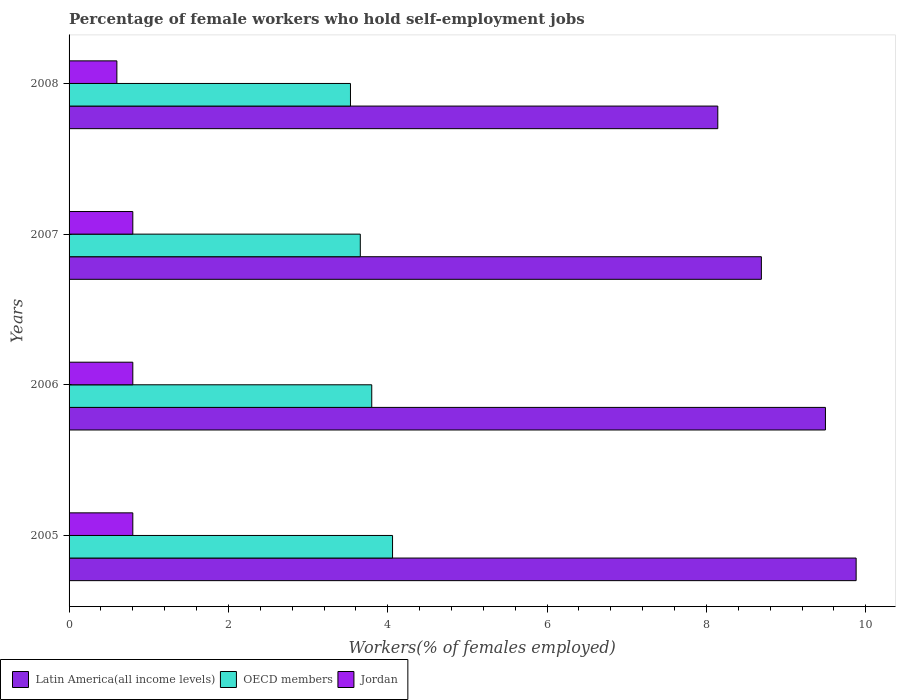Are the number of bars per tick equal to the number of legend labels?
Provide a short and direct response. Yes. Are the number of bars on each tick of the Y-axis equal?
Your response must be concise. Yes. How many bars are there on the 3rd tick from the bottom?
Offer a very short reply. 3. What is the label of the 3rd group of bars from the top?
Your answer should be very brief. 2006. What is the percentage of self-employed female workers in Latin America(all income levels) in 2007?
Provide a short and direct response. 8.69. Across all years, what is the maximum percentage of self-employed female workers in Jordan?
Make the answer very short. 0.8. Across all years, what is the minimum percentage of self-employed female workers in OECD members?
Offer a terse response. 3.53. In which year was the percentage of self-employed female workers in Latin America(all income levels) maximum?
Your answer should be very brief. 2005. In which year was the percentage of self-employed female workers in Latin America(all income levels) minimum?
Your response must be concise. 2008. What is the total percentage of self-employed female workers in Latin America(all income levels) in the graph?
Ensure brevity in your answer.  36.2. What is the difference between the percentage of self-employed female workers in OECD members in 2007 and that in 2008?
Make the answer very short. 0.12. What is the difference between the percentage of self-employed female workers in Latin America(all income levels) in 2005 and the percentage of self-employed female workers in Jordan in 2007?
Ensure brevity in your answer.  9.08. What is the average percentage of self-employed female workers in Latin America(all income levels) per year?
Provide a succinct answer. 9.05. In the year 2008, what is the difference between the percentage of self-employed female workers in OECD members and percentage of self-employed female workers in Latin America(all income levels)?
Your response must be concise. -4.61. In how many years, is the percentage of self-employed female workers in Latin America(all income levels) greater than 0.8 %?
Provide a short and direct response. 4. What is the ratio of the percentage of self-employed female workers in Latin America(all income levels) in 2007 to that in 2008?
Offer a very short reply. 1.07. Is the percentage of self-employed female workers in Latin America(all income levels) in 2005 less than that in 2007?
Give a very brief answer. No. Is the difference between the percentage of self-employed female workers in OECD members in 2007 and 2008 greater than the difference between the percentage of self-employed female workers in Latin America(all income levels) in 2007 and 2008?
Give a very brief answer. No. What is the difference between the highest and the second highest percentage of self-employed female workers in OECD members?
Your answer should be compact. 0.26. What is the difference between the highest and the lowest percentage of self-employed female workers in OECD members?
Keep it short and to the point. 0.53. In how many years, is the percentage of self-employed female workers in Latin America(all income levels) greater than the average percentage of self-employed female workers in Latin America(all income levels) taken over all years?
Ensure brevity in your answer.  2. Is the sum of the percentage of self-employed female workers in Latin America(all income levels) in 2005 and 2008 greater than the maximum percentage of self-employed female workers in Jordan across all years?
Offer a very short reply. Yes. What does the 2nd bar from the top in 2006 represents?
Ensure brevity in your answer.  OECD members. What does the 3rd bar from the bottom in 2008 represents?
Your answer should be compact. Jordan. Is it the case that in every year, the sum of the percentage of self-employed female workers in OECD members and percentage of self-employed female workers in Latin America(all income levels) is greater than the percentage of self-employed female workers in Jordan?
Ensure brevity in your answer.  Yes. How many bars are there?
Your response must be concise. 12. Are all the bars in the graph horizontal?
Keep it short and to the point. Yes. How many years are there in the graph?
Make the answer very short. 4. Does the graph contain any zero values?
Provide a short and direct response. No. Does the graph contain grids?
Offer a very short reply. No. Where does the legend appear in the graph?
Provide a short and direct response. Bottom left. How many legend labels are there?
Offer a very short reply. 3. What is the title of the graph?
Offer a terse response. Percentage of female workers who hold self-employment jobs. Does "Guyana" appear as one of the legend labels in the graph?
Offer a very short reply. No. What is the label or title of the X-axis?
Your answer should be compact. Workers(% of females employed). What is the Workers(% of females employed) in Latin America(all income levels) in 2005?
Keep it short and to the point. 9.88. What is the Workers(% of females employed) of OECD members in 2005?
Provide a short and direct response. 4.06. What is the Workers(% of females employed) of Jordan in 2005?
Provide a short and direct response. 0.8. What is the Workers(% of females employed) in Latin America(all income levels) in 2006?
Provide a short and direct response. 9.49. What is the Workers(% of females employed) of OECD members in 2006?
Give a very brief answer. 3.8. What is the Workers(% of females employed) in Jordan in 2006?
Make the answer very short. 0.8. What is the Workers(% of females employed) of Latin America(all income levels) in 2007?
Keep it short and to the point. 8.69. What is the Workers(% of females employed) of OECD members in 2007?
Your answer should be very brief. 3.66. What is the Workers(% of females employed) of Jordan in 2007?
Provide a short and direct response. 0.8. What is the Workers(% of females employed) of Latin America(all income levels) in 2008?
Your answer should be compact. 8.14. What is the Workers(% of females employed) in OECD members in 2008?
Provide a succinct answer. 3.53. What is the Workers(% of females employed) of Jordan in 2008?
Your answer should be very brief. 0.6. Across all years, what is the maximum Workers(% of females employed) of Latin America(all income levels)?
Offer a very short reply. 9.88. Across all years, what is the maximum Workers(% of females employed) of OECD members?
Keep it short and to the point. 4.06. Across all years, what is the maximum Workers(% of females employed) of Jordan?
Your response must be concise. 0.8. Across all years, what is the minimum Workers(% of females employed) of Latin America(all income levels)?
Offer a very short reply. 8.14. Across all years, what is the minimum Workers(% of females employed) of OECD members?
Offer a very short reply. 3.53. Across all years, what is the minimum Workers(% of females employed) of Jordan?
Your answer should be very brief. 0.6. What is the total Workers(% of females employed) of Latin America(all income levels) in the graph?
Offer a terse response. 36.2. What is the total Workers(% of females employed) of OECD members in the graph?
Your response must be concise. 15.05. What is the difference between the Workers(% of females employed) of Latin America(all income levels) in 2005 and that in 2006?
Your answer should be very brief. 0.39. What is the difference between the Workers(% of females employed) in OECD members in 2005 and that in 2006?
Provide a short and direct response. 0.26. What is the difference between the Workers(% of females employed) of Latin America(all income levels) in 2005 and that in 2007?
Offer a very short reply. 1.19. What is the difference between the Workers(% of females employed) of OECD members in 2005 and that in 2007?
Provide a succinct answer. 0.4. What is the difference between the Workers(% of females employed) in Jordan in 2005 and that in 2007?
Ensure brevity in your answer.  0. What is the difference between the Workers(% of females employed) in Latin America(all income levels) in 2005 and that in 2008?
Ensure brevity in your answer.  1.74. What is the difference between the Workers(% of females employed) of OECD members in 2005 and that in 2008?
Offer a very short reply. 0.53. What is the difference between the Workers(% of females employed) of Latin America(all income levels) in 2006 and that in 2007?
Offer a terse response. 0.8. What is the difference between the Workers(% of females employed) of OECD members in 2006 and that in 2007?
Your response must be concise. 0.14. What is the difference between the Workers(% of females employed) in Latin America(all income levels) in 2006 and that in 2008?
Provide a short and direct response. 1.35. What is the difference between the Workers(% of females employed) of OECD members in 2006 and that in 2008?
Make the answer very short. 0.27. What is the difference between the Workers(% of females employed) of Jordan in 2006 and that in 2008?
Your answer should be very brief. 0.2. What is the difference between the Workers(% of females employed) in Latin America(all income levels) in 2007 and that in 2008?
Your answer should be very brief. 0.55. What is the difference between the Workers(% of females employed) of OECD members in 2007 and that in 2008?
Keep it short and to the point. 0.12. What is the difference between the Workers(% of females employed) in Latin America(all income levels) in 2005 and the Workers(% of females employed) in OECD members in 2006?
Give a very brief answer. 6.08. What is the difference between the Workers(% of females employed) in Latin America(all income levels) in 2005 and the Workers(% of females employed) in Jordan in 2006?
Ensure brevity in your answer.  9.08. What is the difference between the Workers(% of females employed) in OECD members in 2005 and the Workers(% of females employed) in Jordan in 2006?
Your response must be concise. 3.26. What is the difference between the Workers(% of females employed) in Latin America(all income levels) in 2005 and the Workers(% of females employed) in OECD members in 2007?
Make the answer very short. 6.22. What is the difference between the Workers(% of females employed) in Latin America(all income levels) in 2005 and the Workers(% of females employed) in Jordan in 2007?
Make the answer very short. 9.08. What is the difference between the Workers(% of females employed) of OECD members in 2005 and the Workers(% of females employed) of Jordan in 2007?
Your answer should be very brief. 3.26. What is the difference between the Workers(% of females employed) in Latin America(all income levels) in 2005 and the Workers(% of females employed) in OECD members in 2008?
Keep it short and to the point. 6.35. What is the difference between the Workers(% of females employed) of Latin America(all income levels) in 2005 and the Workers(% of females employed) of Jordan in 2008?
Make the answer very short. 9.28. What is the difference between the Workers(% of females employed) in OECD members in 2005 and the Workers(% of females employed) in Jordan in 2008?
Keep it short and to the point. 3.46. What is the difference between the Workers(% of females employed) in Latin America(all income levels) in 2006 and the Workers(% of females employed) in OECD members in 2007?
Give a very brief answer. 5.84. What is the difference between the Workers(% of females employed) in Latin America(all income levels) in 2006 and the Workers(% of females employed) in Jordan in 2007?
Offer a very short reply. 8.69. What is the difference between the Workers(% of females employed) in OECD members in 2006 and the Workers(% of females employed) in Jordan in 2007?
Keep it short and to the point. 3. What is the difference between the Workers(% of females employed) in Latin America(all income levels) in 2006 and the Workers(% of females employed) in OECD members in 2008?
Keep it short and to the point. 5.96. What is the difference between the Workers(% of females employed) in Latin America(all income levels) in 2006 and the Workers(% of females employed) in Jordan in 2008?
Your response must be concise. 8.89. What is the difference between the Workers(% of females employed) in OECD members in 2006 and the Workers(% of females employed) in Jordan in 2008?
Your response must be concise. 3.2. What is the difference between the Workers(% of females employed) of Latin America(all income levels) in 2007 and the Workers(% of females employed) of OECD members in 2008?
Give a very brief answer. 5.16. What is the difference between the Workers(% of females employed) in Latin America(all income levels) in 2007 and the Workers(% of females employed) in Jordan in 2008?
Ensure brevity in your answer.  8.09. What is the difference between the Workers(% of females employed) in OECD members in 2007 and the Workers(% of females employed) in Jordan in 2008?
Your answer should be compact. 3.06. What is the average Workers(% of females employed) of Latin America(all income levels) per year?
Offer a terse response. 9.05. What is the average Workers(% of females employed) of OECD members per year?
Your response must be concise. 3.76. In the year 2005, what is the difference between the Workers(% of females employed) of Latin America(all income levels) and Workers(% of females employed) of OECD members?
Provide a short and direct response. 5.82. In the year 2005, what is the difference between the Workers(% of females employed) of Latin America(all income levels) and Workers(% of females employed) of Jordan?
Your response must be concise. 9.08. In the year 2005, what is the difference between the Workers(% of females employed) of OECD members and Workers(% of females employed) of Jordan?
Provide a short and direct response. 3.26. In the year 2006, what is the difference between the Workers(% of females employed) in Latin America(all income levels) and Workers(% of females employed) in OECD members?
Ensure brevity in your answer.  5.69. In the year 2006, what is the difference between the Workers(% of females employed) of Latin America(all income levels) and Workers(% of females employed) of Jordan?
Provide a short and direct response. 8.69. In the year 2006, what is the difference between the Workers(% of females employed) in OECD members and Workers(% of females employed) in Jordan?
Provide a succinct answer. 3. In the year 2007, what is the difference between the Workers(% of females employed) in Latin America(all income levels) and Workers(% of females employed) in OECD members?
Your response must be concise. 5.03. In the year 2007, what is the difference between the Workers(% of females employed) of Latin America(all income levels) and Workers(% of females employed) of Jordan?
Your answer should be very brief. 7.89. In the year 2007, what is the difference between the Workers(% of females employed) in OECD members and Workers(% of females employed) in Jordan?
Provide a short and direct response. 2.86. In the year 2008, what is the difference between the Workers(% of females employed) of Latin America(all income levels) and Workers(% of females employed) of OECD members?
Offer a terse response. 4.61. In the year 2008, what is the difference between the Workers(% of females employed) of Latin America(all income levels) and Workers(% of females employed) of Jordan?
Give a very brief answer. 7.54. In the year 2008, what is the difference between the Workers(% of females employed) of OECD members and Workers(% of females employed) of Jordan?
Ensure brevity in your answer.  2.93. What is the ratio of the Workers(% of females employed) of Latin America(all income levels) in 2005 to that in 2006?
Make the answer very short. 1.04. What is the ratio of the Workers(% of females employed) in OECD members in 2005 to that in 2006?
Give a very brief answer. 1.07. What is the ratio of the Workers(% of females employed) of Latin America(all income levels) in 2005 to that in 2007?
Offer a terse response. 1.14. What is the ratio of the Workers(% of females employed) in OECD members in 2005 to that in 2007?
Ensure brevity in your answer.  1.11. What is the ratio of the Workers(% of females employed) of Latin America(all income levels) in 2005 to that in 2008?
Ensure brevity in your answer.  1.21. What is the ratio of the Workers(% of females employed) of OECD members in 2005 to that in 2008?
Your answer should be compact. 1.15. What is the ratio of the Workers(% of females employed) of Latin America(all income levels) in 2006 to that in 2007?
Ensure brevity in your answer.  1.09. What is the ratio of the Workers(% of females employed) in OECD members in 2006 to that in 2007?
Provide a short and direct response. 1.04. What is the ratio of the Workers(% of females employed) of Latin America(all income levels) in 2006 to that in 2008?
Ensure brevity in your answer.  1.17. What is the ratio of the Workers(% of females employed) of OECD members in 2006 to that in 2008?
Ensure brevity in your answer.  1.08. What is the ratio of the Workers(% of females employed) of Jordan in 2006 to that in 2008?
Your answer should be very brief. 1.33. What is the ratio of the Workers(% of females employed) of Latin America(all income levels) in 2007 to that in 2008?
Keep it short and to the point. 1.07. What is the ratio of the Workers(% of females employed) of OECD members in 2007 to that in 2008?
Your answer should be compact. 1.03. What is the ratio of the Workers(% of females employed) in Jordan in 2007 to that in 2008?
Give a very brief answer. 1.33. What is the difference between the highest and the second highest Workers(% of females employed) in Latin America(all income levels)?
Ensure brevity in your answer.  0.39. What is the difference between the highest and the second highest Workers(% of females employed) of OECD members?
Keep it short and to the point. 0.26. What is the difference between the highest and the lowest Workers(% of females employed) of Latin America(all income levels)?
Keep it short and to the point. 1.74. What is the difference between the highest and the lowest Workers(% of females employed) in OECD members?
Give a very brief answer. 0.53. 